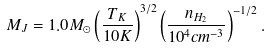Convert formula to latex. <formula><loc_0><loc_0><loc_500><loc_500>M _ { J } = 1 . 0 M _ { \odot } \left ( \frac { T _ { K } } { 1 0 K } \right ) ^ { 3 / 2 } \left ( \frac { n _ { H _ { 2 } } } { 1 0 ^ { 4 } c m ^ { - 3 } } \right ) ^ { - 1 / 2 } .</formula> 